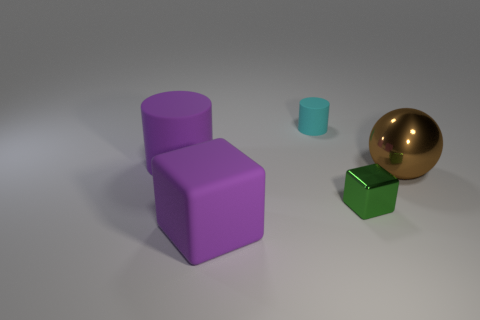There is a big rubber thing that is the same color as the big matte cylinder; what shape is it?
Offer a terse response. Cube. Is there a tiny green thing that has the same material as the big purple cube?
Provide a succinct answer. No. What number of tiny green metallic blocks are there?
Ensure brevity in your answer.  1. Is the purple block made of the same material as the cylinder to the left of the tiny cyan matte thing?
Keep it short and to the point. Yes. There is a cylinder that is the same color as the big matte block; what material is it?
Your response must be concise. Rubber. What number of things have the same color as the large matte cube?
Your answer should be very brief. 1. What is the size of the cyan rubber cylinder?
Provide a short and direct response. Small. There is a cyan rubber object; is its shape the same as the large matte object behind the big brown shiny sphere?
Keep it short and to the point. Yes. There is another cylinder that is the same material as the tiny cyan cylinder; what color is it?
Your answer should be compact. Purple. There is a block on the left side of the tiny cyan matte object; what size is it?
Offer a very short reply. Large. 